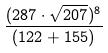Convert formula to latex. <formula><loc_0><loc_0><loc_500><loc_500>\frac { ( 2 8 7 \cdot \sqrt { 2 0 7 } ) ^ { 8 } } { ( 1 2 2 + 1 5 5 ) }</formula> 